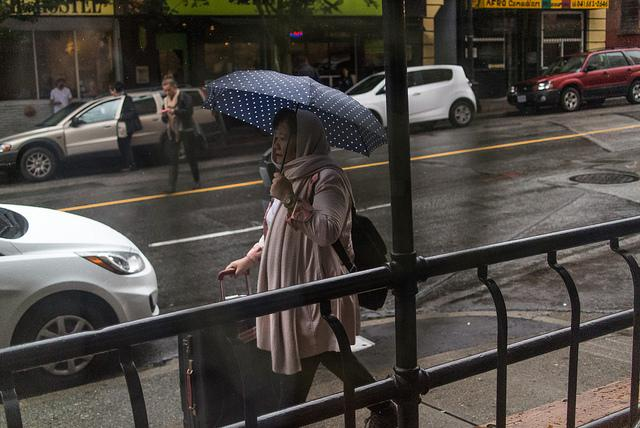Why is the woman carrying luggage?

Choices:
A) to travel
B) to buy
C) to sell
D) to trade to travel 